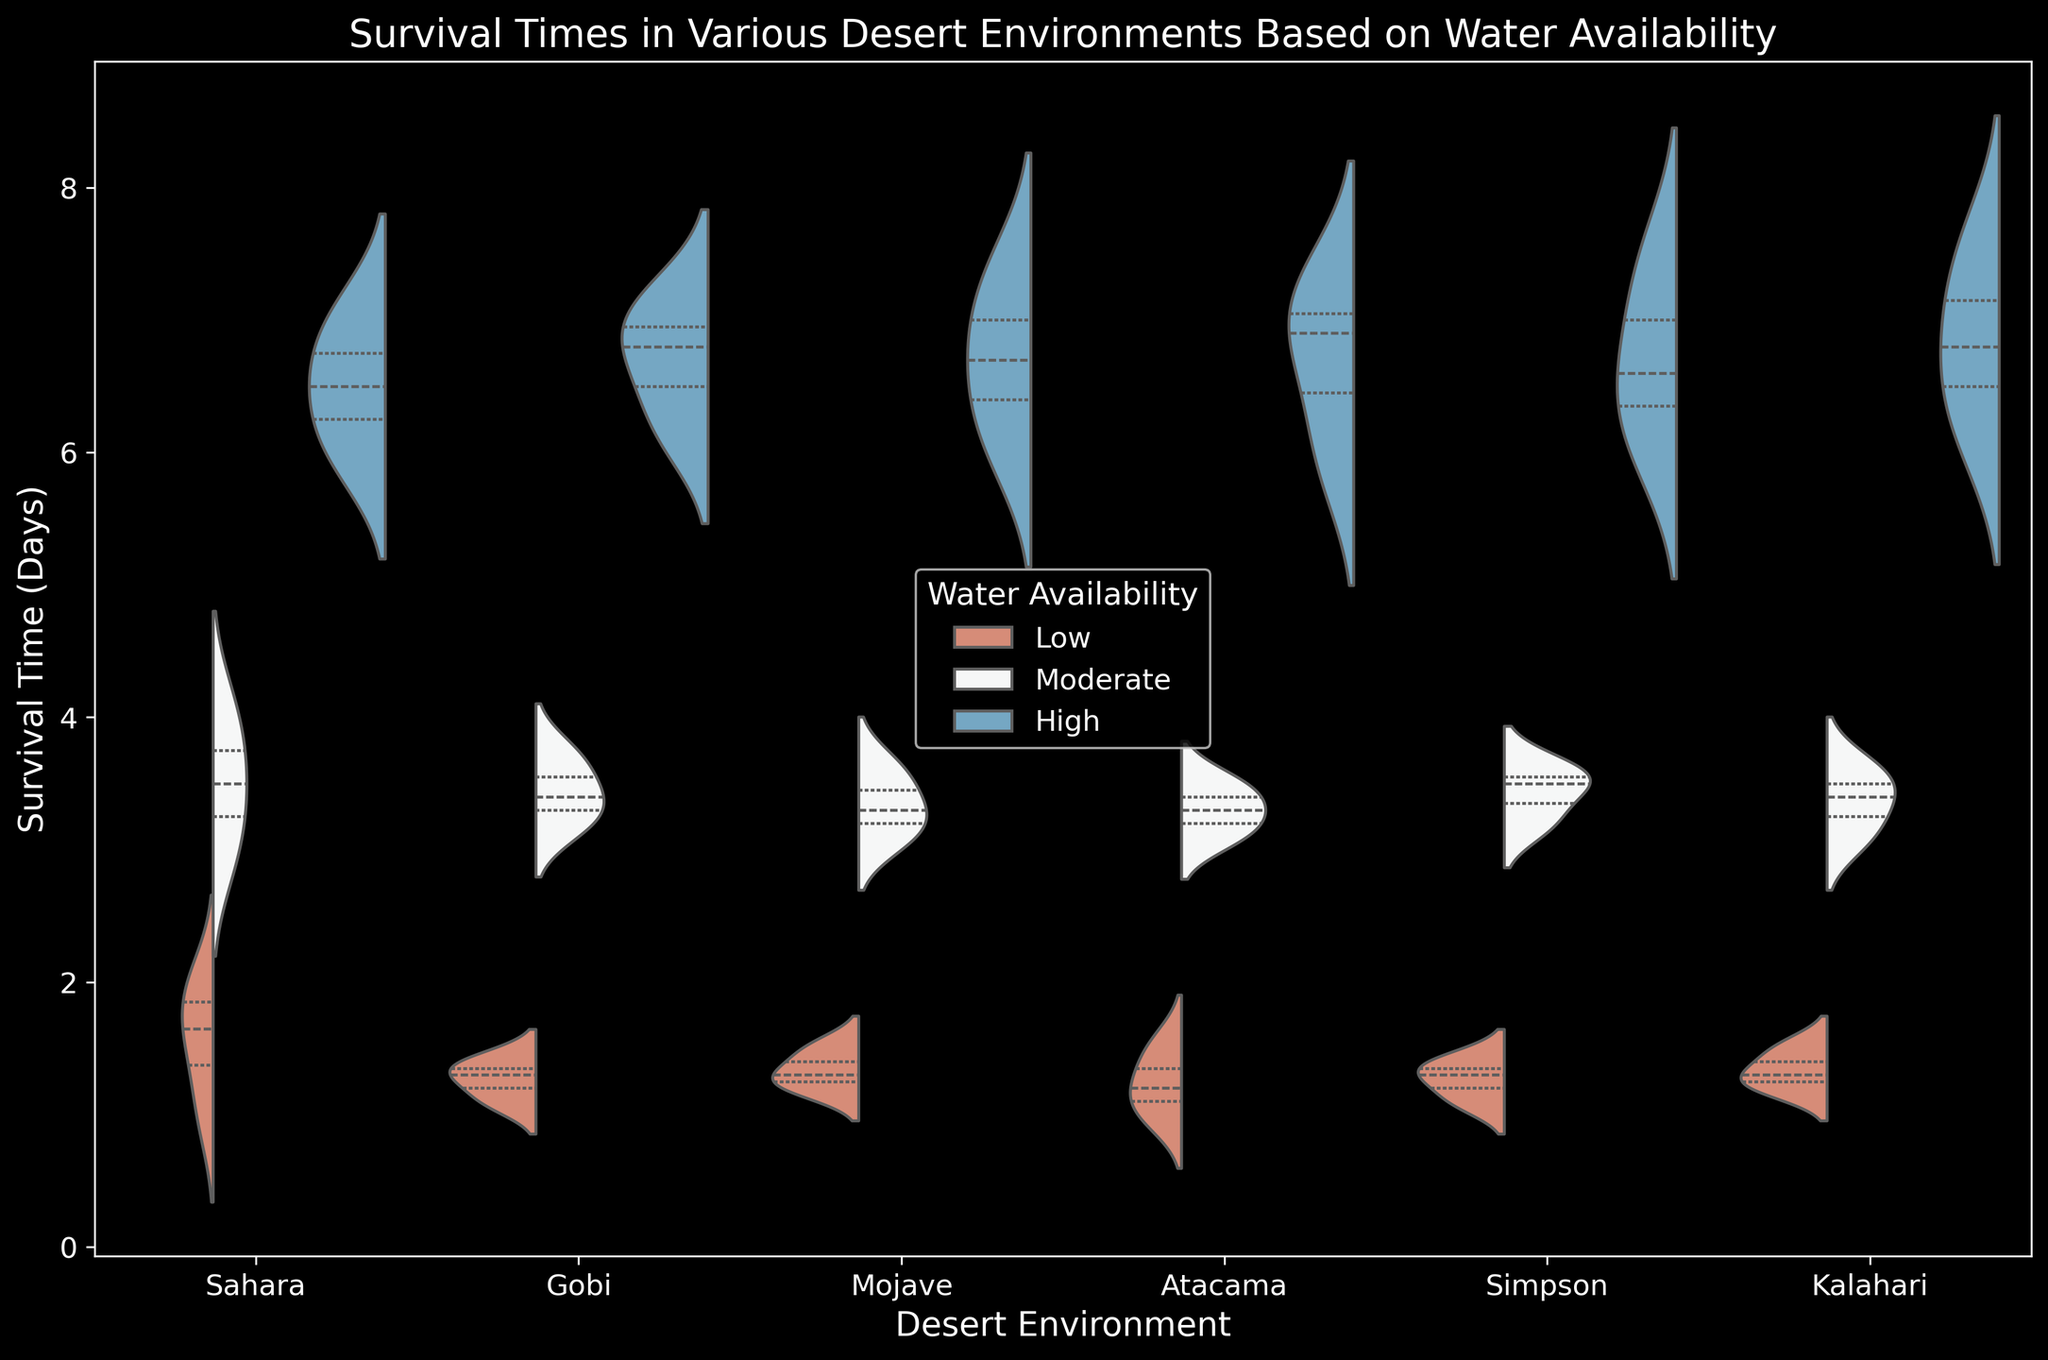What's the median survival time in the Sahara with moderate water availability? Look at the violin plot for the Sahara desert and find the inner quartile (median) marker within the 'Moderate' section. The median value looks around 3.5 days.
Answer: 3.5 days Which desert shows the highest survival time with high water availability? Look at the 'High' water availability sections of all the deserts in the chart. The highest marker is within the Kalahari desert, around 7.5 days.
Answer: Kalahari Compare the average survival times in the Gobi and Mojave deserts with low water availability. Which is higher? Estimate the average for the 'Low' water availability sections of Gobi and Mojave by looking at the distribution centers. Gobi's average is slightly above 1.2 days, while Mojave's is around 1.3 days. Mojave is higher.
Answer: Mojave What is the spread of survival times in the Simpson desert with high water availability? Locate the 'High' water availability section for Simpson. The spread ranges from around 6.1 to 7.4 days.
Answer: 6.1 to 7.4 days Between the Atacama and Sahara deserts, which has a broader range of survival times with moderate water availability? Compare the 'Moderate' water availability sections for Atacama and Sahara. Sahara's range is from about 3 to 4 days, while Atacama's is roughly from 3.1 to 3.5 days. Sahara has a broader range.
Answer: Sahara Which environment shows the least variation in survival times with low water availability? Inspect the 'Low' water availability sections across all environments. The ranges are closely packed, but Atacama has a slightly narrower spread from 1 to 1.5 days.
Answer: Atacama What is the highest survival time observed in the Sahara desert with low water availability? In the Sahara section under 'Low' water availability, the highest point reaches up to 2 days.
Answer: 2 days 